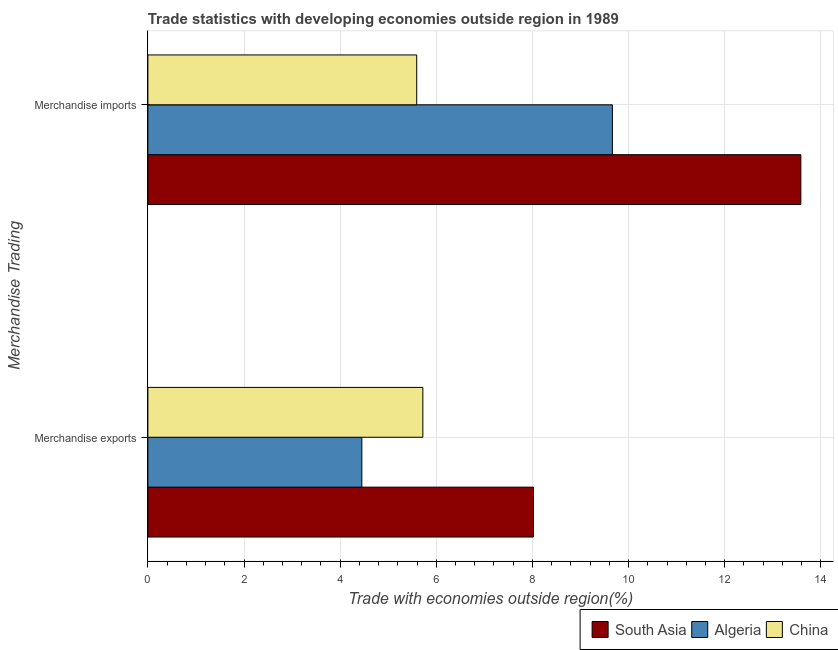Are the number of bars per tick equal to the number of legend labels?
Offer a terse response. Yes. How many bars are there on the 2nd tick from the top?
Keep it short and to the point. 3. How many bars are there on the 2nd tick from the bottom?
Provide a short and direct response. 3. What is the label of the 1st group of bars from the top?
Your response must be concise. Merchandise imports. What is the merchandise imports in China?
Provide a succinct answer. 5.59. Across all countries, what is the maximum merchandise imports?
Your answer should be compact. 13.58. Across all countries, what is the minimum merchandise imports?
Keep it short and to the point. 5.59. In which country was the merchandise exports maximum?
Keep it short and to the point. South Asia. In which country was the merchandise exports minimum?
Keep it short and to the point. Algeria. What is the total merchandise imports in the graph?
Your answer should be compact. 28.84. What is the difference between the merchandise exports in South Asia and that in China?
Your response must be concise. 2.3. What is the difference between the merchandise exports in China and the merchandise imports in Algeria?
Provide a succinct answer. -3.94. What is the average merchandise exports per country?
Your response must be concise. 6.06. What is the difference between the merchandise exports and merchandise imports in Algeria?
Keep it short and to the point. -5.21. In how many countries, is the merchandise imports greater than 12 %?
Offer a terse response. 1. What is the ratio of the merchandise exports in China to that in South Asia?
Your answer should be very brief. 0.71. In how many countries, is the merchandise exports greater than the average merchandise exports taken over all countries?
Ensure brevity in your answer.  1. What does the 2nd bar from the top in Merchandise exports represents?
Your answer should be very brief. Algeria. What does the 3rd bar from the bottom in Merchandise exports represents?
Give a very brief answer. China. Are all the bars in the graph horizontal?
Give a very brief answer. Yes. How many countries are there in the graph?
Provide a succinct answer. 3. What is the difference between two consecutive major ticks on the X-axis?
Your answer should be compact. 2. Are the values on the major ticks of X-axis written in scientific E-notation?
Provide a short and direct response. No. Does the graph contain any zero values?
Provide a succinct answer. No. How are the legend labels stacked?
Keep it short and to the point. Horizontal. What is the title of the graph?
Keep it short and to the point. Trade statistics with developing economies outside region in 1989. Does "Cabo Verde" appear as one of the legend labels in the graph?
Your response must be concise. No. What is the label or title of the X-axis?
Your response must be concise. Trade with economies outside region(%). What is the label or title of the Y-axis?
Ensure brevity in your answer.  Merchandise Trading. What is the Trade with economies outside region(%) of South Asia in Merchandise exports?
Ensure brevity in your answer.  8.02. What is the Trade with economies outside region(%) of Algeria in Merchandise exports?
Offer a very short reply. 4.45. What is the Trade with economies outside region(%) of China in Merchandise exports?
Make the answer very short. 5.72. What is the Trade with economies outside region(%) of South Asia in Merchandise imports?
Your response must be concise. 13.58. What is the Trade with economies outside region(%) of Algeria in Merchandise imports?
Offer a terse response. 9.66. What is the Trade with economies outside region(%) of China in Merchandise imports?
Keep it short and to the point. 5.59. Across all Merchandise Trading, what is the maximum Trade with economies outside region(%) in South Asia?
Give a very brief answer. 13.58. Across all Merchandise Trading, what is the maximum Trade with economies outside region(%) in Algeria?
Your answer should be compact. 9.66. Across all Merchandise Trading, what is the maximum Trade with economies outside region(%) in China?
Ensure brevity in your answer.  5.72. Across all Merchandise Trading, what is the minimum Trade with economies outside region(%) of South Asia?
Keep it short and to the point. 8.02. Across all Merchandise Trading, what is the minimum Trade with economies outside region(%) in Algeria?
Your response must be concise. 4.45. Across all Merchandise Trading, what is the minimum Trade with economies outside region(%) of China?
Make the answer very short. 5.59. What is the total Trade with economies outside region(%) in South Asia in the graph?
Your answer should be compact. 21.61. What is the total Trade with economies outside region(%) in Algeria in the graph?
Keep it short and to the point. 14.11. What is the total Trade with economies outside region(%) of China in the graph?
Make the answer very short. 11.31. What is the difference between the Trade with economies outside region(%) in South Asia in Merchandise exports and that in Merchandise imports?
Your response must be concise. -5.56. What is the difference between the Trade with economies outside region(%) in Algeria in Merchandise exports and that in Merchandise imports?
Your answer should be very brief. -5.21. What is the difference between the Trade with economies outside region(%) of China in Merchandise exports and that in Merchandise imports?
Provide a succinct answer. 0.13. What is the difference between the Trade with economies outside region(%) in South Asia in Merchandise exports and the Trade with economies outside region(%) in Algeria in Merchandise imports?
Ensure brevity in your answer.  -1.64. What is the difference between the Trade with economies outside region(%) in South Asia in Merchandise exports and the Trade with economies outside region(%) in China in Merchandise imports?
Your answer should be compact. 2.43. What is the difference between the Trade with economies outside region(%) in Algeria in Merchandise exports and the Trade with economies outside region(%) in China in Merchandise imports?
Offer a terse response. -1.14. What is the average Trade with economies outside region(%) of South Asia per Merchandise Trading?
Ensure brevity in your answer.  10.8. What is the average Trade with economies outside region(%) of Algeria per Merchandise Trading?
Offer a very short reply. 7.06. What is the average Trade with economies outside region(%) in China per Merchandise Trading?
Your response must be concise. 5.66. What is the difference between the Trade with economies outside region(%) of South Asia and Trade with economies outside region(%) of Algeria in Merchandise exports?
Your answer should be very brief. 3.57. What is the difference between the Trade with economies outside region(%) of South Asia and Trade with economies outside region(%) of China in Merchandise exports?
Your answer should be very brief. 2.3. What is the difference between the Trade with economies outside region(%) of Algeria and Trade with economies outside region(%) of China in Merchandise exports?
Your answer should be compact. -1.27. What is the difference between the Trade with economies outside region(%) of South Asia and Trade with economies outside region(%) of Algeria in Merchandise imports?
Offer a terse response. 3.92. What is the difference between the Trade with economies outside region(%) of South Asia and Trade with economies outside region(%) of China in Merchandise imports?
Your answer should be compact. 7.99. What is the difference between the Trade with economies outside region(%) of Algeria and Trade with economies outside region(%) of China in Merchandise imports?
Provide a short and direct response. 4.07. What is the ratio of the Trade with economies outside region(%) of South Asia in Merchandise exports to that in Merchandise imports?
Make the answer very short. 0.59. What is the ratio of the Trade with economies outside region(%) of Algeria in Merchandise exports to that in Merchandise imports?
Give a very brief answer. 0.46. What is the ratio of the Trade with economies outside region(%) in China in Merchandise exports to that in Merchandise imports?
Your response must be concise. 1.02. What is the difference between the highest and the second highest Trade with economies outside region(%) in South Asia?
Your response must be concise. 5.56. What is the difference between the highest and the second highest Trade with economies outside region(%) of Algeria?
Give a very brief answer. 5.21. What is the difference between the highest and the second highest Trade with economies outside region(%) in China?
Your answer should be very brief. 0.13. What is the difference between the highest and the lowest Trade with economies outside region(%) of South Asia?
Give a very brief answer. 5.56. What is the difference between the highest and the lowest Trade with economies outside region(%) in Algeria?
Provide a short and direct response. 5.21. What is the difference between the highest and the lowest Trade with economies outside region(%) in China?
Make the answer very short. 0.13. 